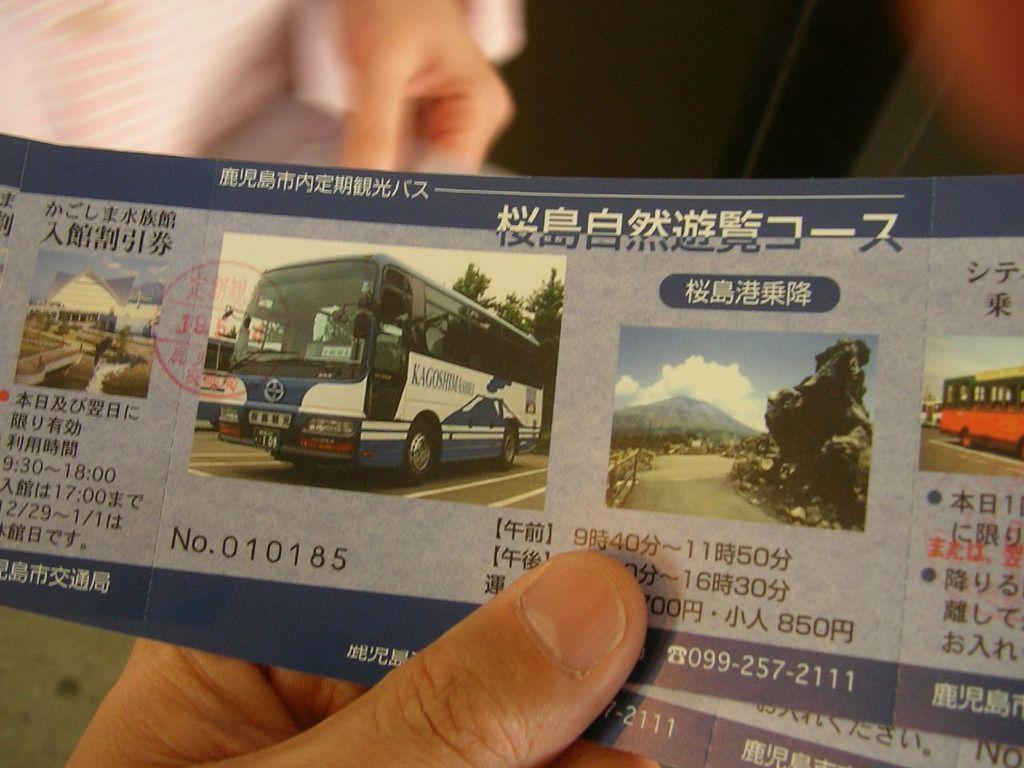What is the person in the image holding? The person in the image is holding tickets. Can you describe the other person visible in the image? The other person is visible in the background of the image, but it is blurry. What type of milk is being served at the event in the image? There is no mention of milk or an event in the image, so it cannot be determined from the image. 